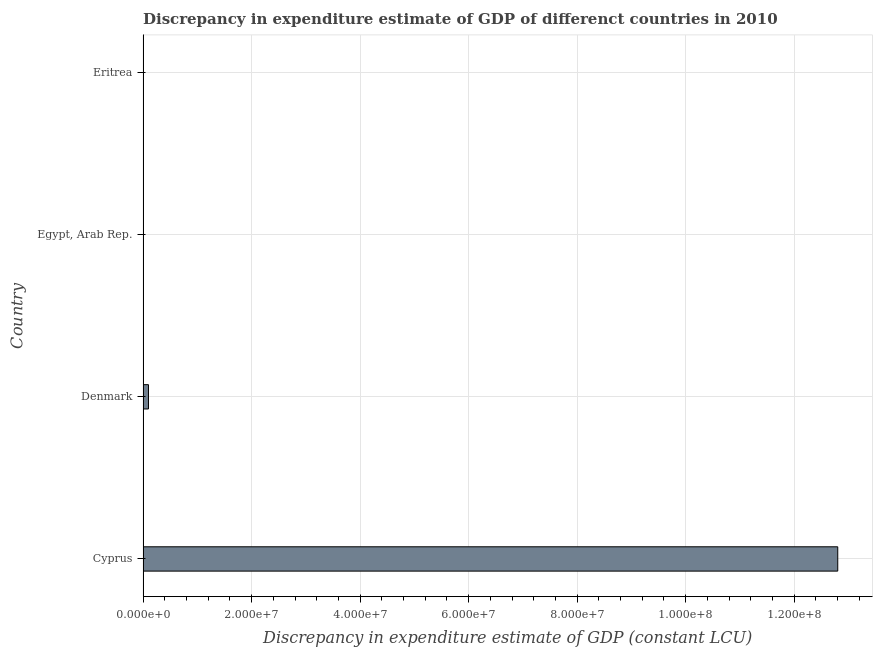Does the graph contain any zero values?
Ensure brevity in your answer.  Yes. What is the title of the graph?
Your answer should be very brief. Discrepancy in expenditure estimate of GDP of differenct countries in 2010. What is the label or title of the X-axis?
Offer a terse response. Discrepancy in expenditure estimate of GDP (constant LCU). What is the discrepancy in expenditure estimate of gdp in Cyprus?
Offer a very short reply. 1.28e+08. Across all countries, what is the maximum discrepancy in expenditure estimate of gdp?
Your response must be concise. 1.28e+08. Across all countries, what is the minimum discrepancy in expenditure estimate of gdp?
Give a very brief answer. 0. In which country was the discrepancy in expenditure estimate of gdp maximum?
Make the answer very short. Cyprus. What is the sum of the discrepancy in expenditure estimate of gdp?
Offer a very short reply. 1.29e+08. What is the average discrepancy in expenditure estimate of gdp per country?
Offer a terse response. 3.23e+07. What is the median discrepancy in expenditure estimate of gdp?
Ensure brevity in your answer.  5.00e+05. In how many countries, is the discrepancy in expenditure estimate of gdp greater than 24000000 LCU?
Offer a terse response. 1. What is the ratio of the discrepancy in expenditure estimate of gdp in Denmark to that in Eritrea?
Give a very brief answer. 5.00e+09. Is the discrepancy in expenditure estimate of gdp in Cyprus less than that in Eritrea?
Offer a terse response. No. What is the difference between the highest and the second highest discrepancy in expenditure estimate of gdp?
Make the answer very short. 1.27e+08. Is the sum of the discrepancy in expenditure estimate of gdp in Cyprus and Denmark greater than the maximum discrepancy in expenditure estimate of gdp across all countries?
Give a very brief answer. Yes. What is the difference between the highest and the lowest discrepancy in expenditure estimate of gdp?
Give a very brief answer. 1.28e+08. In how many countries, is the discrepancy in expenditure estimate of gdp greater than the average discrepancy in expenditure estimate of gdp taken over all countries?
Provide a succinct answer. 1. How many bars are there?
Offer a terse response. 3. What is the difference between two consecutive major ticks on the X-axis?
Give a very brief answer. 2.00e+07. What is the Discrepancy in expenditure estimate of GDP (constant LCU) in Cyprus?
Your answer should be compact. 1.28e+08. What is the Discrepancy in expenditure estimate of GDP (constant LCU) in Denmark?
Give a very brief answer. 1.00e+06. What is the difference between the Discrepancy in expenditure estimate of GDP (constant LCU) in Cyprus and Denmark?
Ensure brevity in your answer.  1.27e+08. What is the difference between the Discrepancy in expenditure estimate of GDP (constant LCU) in Cyprus and Eritrea?
Your answer should be very brief. 1.28e+08. What is the difference between the Discrepancy in expenditure estimate of GDP (constant LCU) in Denmark and Eritrea?
Provide a succinct answer. 1.00e+06. What is the ratio of the Discrepancy in expenditure estimate of GDP (constant LCU) in Cyprus to that in Denmark?
Make the answer very short. 128.03. What is the ratio of the Discrepancy in expenditure estimate of GDP (constant LCU) in Cyprus to that in Eritrea?
Your answer should be compact. 6.40e+11. What is the ratio of the Discrepancy in expenditure estimate of GDP (constant LCU) in Denmark to that in Eritrea?
Keep it short and to the point. 5.00e+09. 